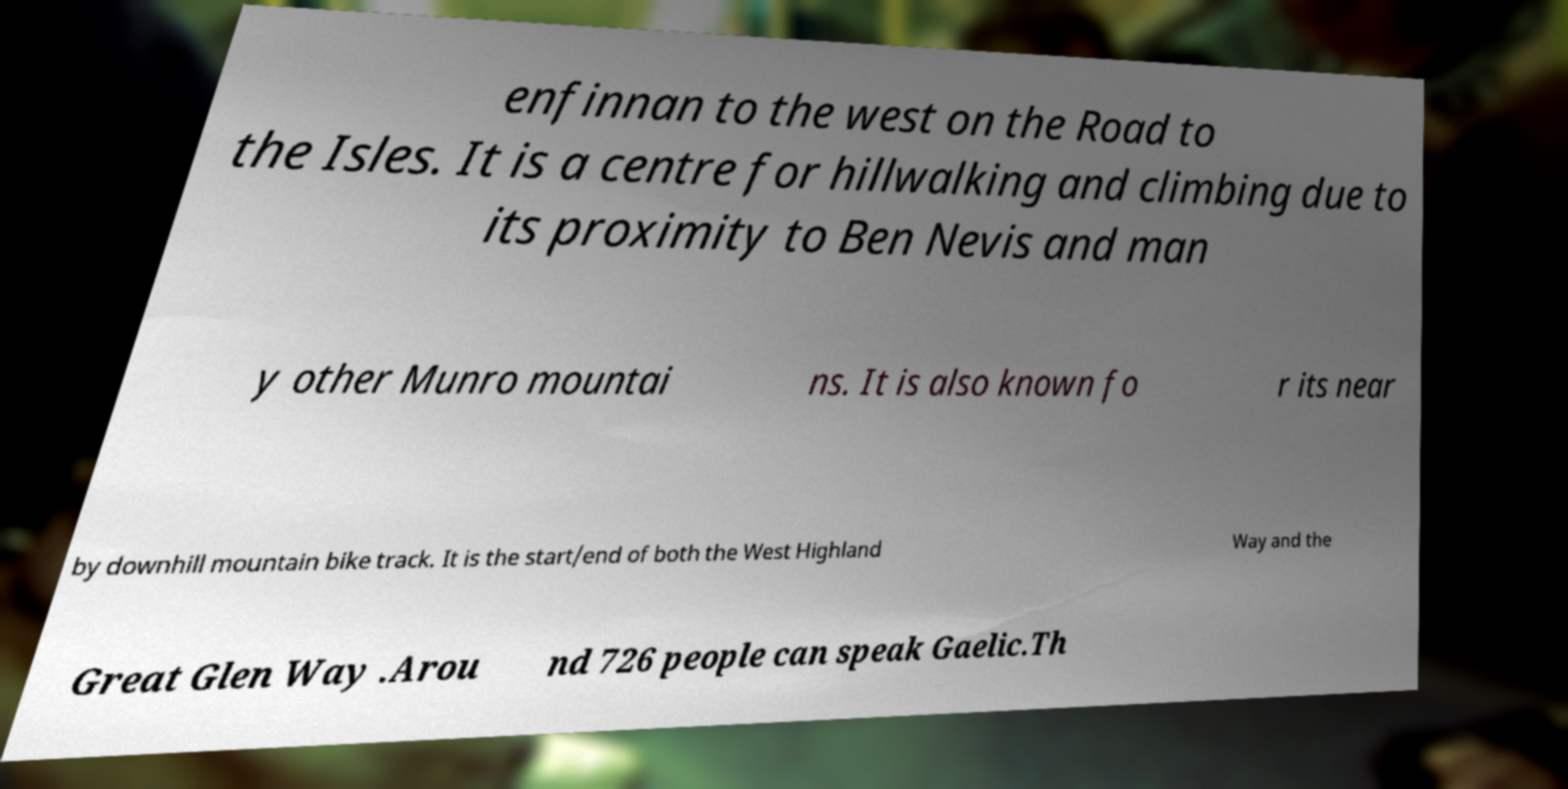Could you extract and type out the text from this image? enfinnan to the west on the Road to the Isles. It is a centre for hillwalking and climbing due to its proximity to Ben Nevis and man y other Munro mountai ns. It is also known fo r its near by downhill mountain bike track. It is the start/end of both the West Highland Way and the Great Glen Way .Arou nd 726 people can speak Gaelic.Th 